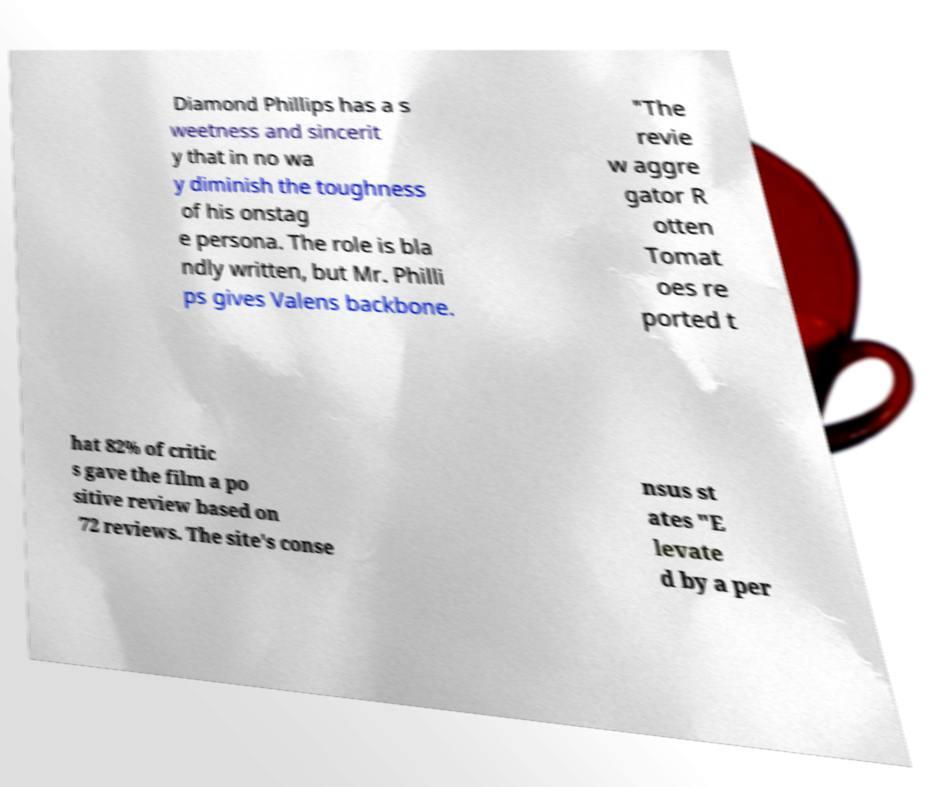There's text embedded in this image that I need extracted. Can you transcribe it verbatim? Diamond Phillips has a s weetness and sincerit y that in no wa y diminish the toughness of his onstag e persona. The role is bla ndly written, but Mr. Philli ps gives Valens backbone. "The revie w aggre gator R otten Tomat oes re ported t hat 82% of critic s gave the film a po sitive review based on 72 reviews. The site's conse nsus st ates "E levate d by a per 